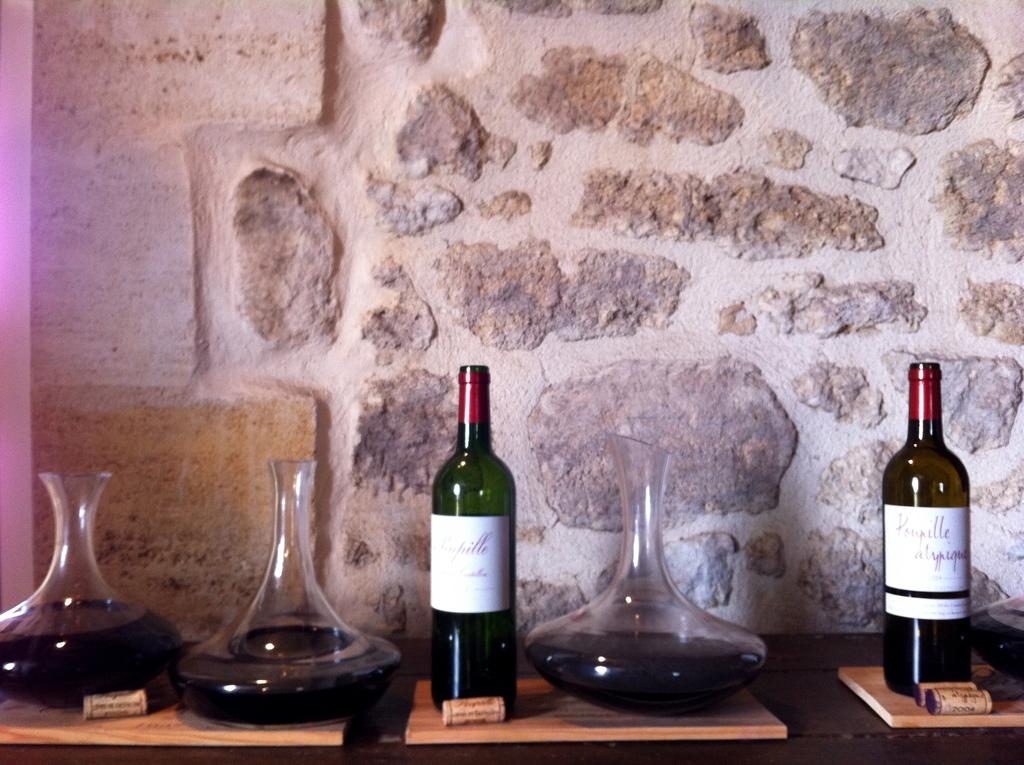How many wine bottles are visible in the image? There are 2 wine bottles in the image. What other items can be seen in the image besides the wine bottles? There are jars in the image. What can be seen in the background of the image? There is a wall in the background of the image. What is the current opinion of the wine bottles in the image? There is no indication of any opinions about the wine bottles in the image, as it is a still image and does not convey emotions or opinions. 